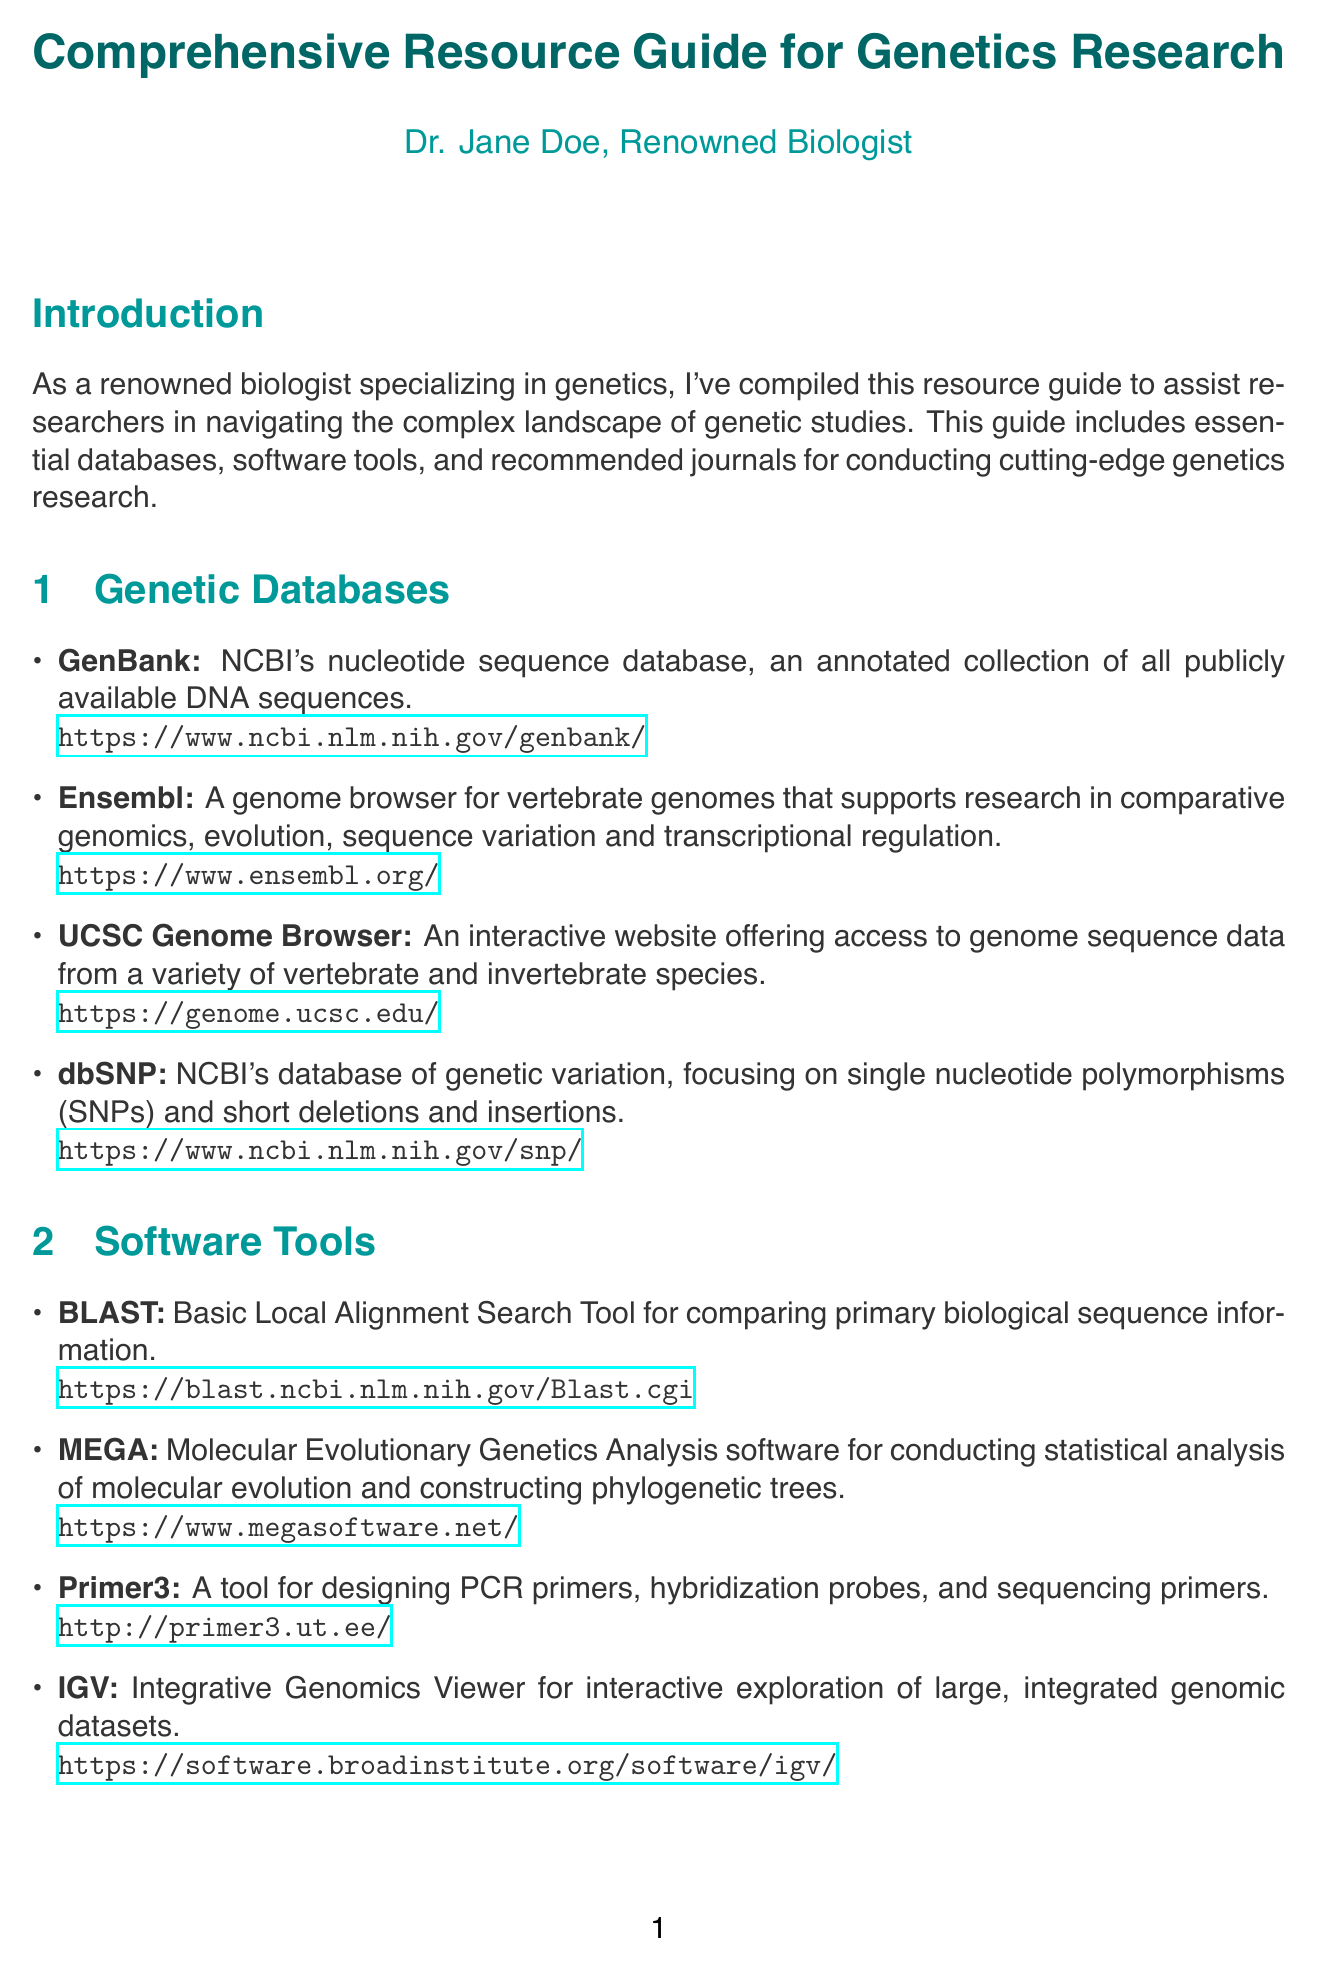What is the title of the document? The title of the document is stated at the beginning of the manual.
Answer: Comprehensive Resource Guide for Genetics Research How many genetic databases are listed? The section on Genetic Databases mentions four specific databases.
Answer: 4 What is the impact factor of Nature Genetics? The impact factor is highlighted in the section about Recommended Journals.
Answer: 27.605 Which software tool is used for designing PCR primers? The description of software tools includes information about a specific tool for PCR primer design.
Answer: Primer3 What is the primary focus of the journal Genome Research? The journal's focus is mentioned in its description under Recommended Journals.
Answer: Genome-scale analysis What ethical consideration involves obtaining consent? In the Ethical Considerations section, a specific topic addresses the need for consent.
Answer: Informed Consent Which platform is mentioned as an open web-based tool for research? The documentation describes a specific platform that is accessible and web-based.
Answer: Galaxy What type of analysis does PLINK perform? The PLINK tool's function is explained in the Advanced Analysis Tools section.
Answer: Whole genome association analysis What is the URL for the UCSC Genome Browser? The URL for the UCSC Genome Browser is specifically provided in the Genetic Databases section.
Answer: https://genome.ucsc.edu/ 